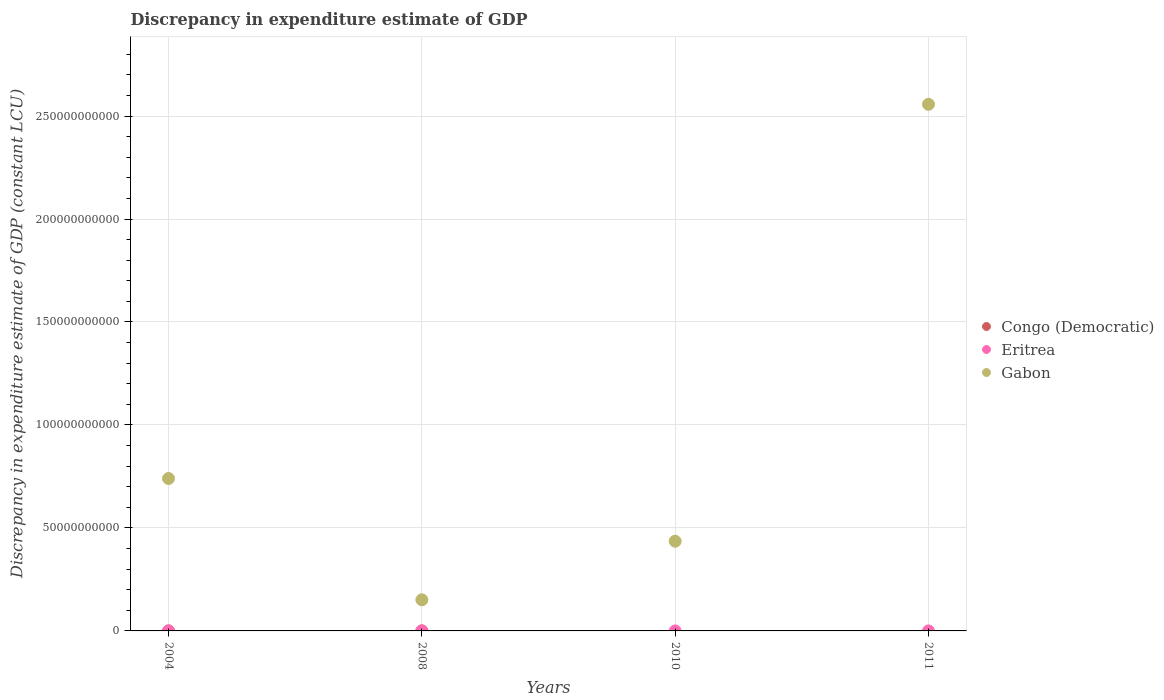What is the discrepancy in expenditure estimate of GDP in Congo (Democratic) in 2004?
Make the answer very short. 0. What is the total discrepancy in expenditure estimate of GDP in Eritrea in the graph?
Keep it short and to the point. 0. What is the difference between the discrepancy in expenditure estimate of GDP in Gabon in 2004 and that in 2008?
Provide a succinct answer. 5.89e+1. What is the difference between the discrepancy in expenditure estimate of GDP in Gabon in 2004 and the discrepancy in expenditure estimate of GDP in Congo (Democratic) in 2008?
Provide a short and direct response. 7.40e+1. In the year 2008, what is the difference between the discrepancy in expenditure estimate of GDP in Gabon and discrepancy in expenditure estimate of GDP in Eritrea?
Your answer should be compact. 1.51e+1. In how many years, is the discrepancy in expenditure estimate of GDP in Eritrea greater than 50000000000 LCU?
Your answer should be very brief. 0. What is the ratio of the discrepancy in expenditure estimate of GDP in Eritrea in 2008 to that in 2010?
Make the answer very short. 0.5. What is the difference between the highest and the second highest discrepancy in expenditure estimate of GDP in Eritrea?
Provide a succinct answer. 0. Is it the case that in every year, the sum of the discrepancy in expenditure estimate of GDP in Congo (Democratic) and discrepancy in expenditure estimate of GDP in Gabon  is greater than the discrepancy in expenditure estimate of GDP in Eritrea?
Make the answer very short. Yes. Is the discrepancy in expenditure estimate of GDP in Gabon strictly less than the discrepancy in expenditure estimate of GDP in Congo (Democratic) over the years?
Provide a short and direct response. No. How many years are there in the graph?
Ensure brevity in your answer.  4. What is the difference between two consecutive major ticks on the Y-axis?
Your response must be concise. 5.00e+1. Does the graph contain grids?
Your response must be concise. Yes. Where does the legend appear in the graph?
Provide a succinct answer. Center right. How many legend labels are there?
Your response must be concise. 3. What is the title of the graph?
Your answer should be very brief. Discrepancy in expenditure estimate of GDP. What is the label or title of the Y-axis?
Your response must be concise. Discrepancy in expenditure estimate of GDP (constant LCU). What is the Discrepancy in expenditure estimate of GDP (constant LCU) of Congo (Democratic) in 2004?
Provide a short and direct response. 0. What is the Discrepancy in expenditure estimate of GDP (constant LCU) in Eritrea in 2004?
Your answer should be very brief. 0. What is the Discrepancy in expenditure estimate of GDP (constant LCU) in Gabon in 2004?
Your answer should be very brief. 7.40e+1. What is the Discrepancy in expenditure estimate of GDP (constant LCU) of Eritrea in 2008?
Make the answer very short. 0. What is the Discrepancy in expenditure estimate of GDP (constant LCU) of Gabon in 2008?
Offer a very short reply. 1.51e+1. What is the Discrepancy in expenditure estimate of GDP (constant LCU) in Gabon in 2010?
Offer a terse response. 4.36e+1. What is the Discrepancy in expenditure estimate of GDP (constant LCU) in Congo (Democratic) in 2011?
Your response must be concise. 0. What is the Discrepancy in expenditure estimate of GDP (constant LCU) of Gabon in 2011?
Your response must be concise. 2.56e+11. Across all years, what is the maximum Discrepancy in expenditure estimate of GDP (constant LCU) in Gabon?
Your answer should be very brief. 2.56e+11. Across all years, what is the minimum Discrepancy in expenditure estimate of GDP (constant LCU) of Gabon?
Make the answer very short. 1.51e+1. What is the total Discrepancy in expenditure estimate of GDP (constant LCU) of Congo (Democratic) in the graph?
Offer a very short reply. 0. What is the total Discrepancy in expenditure estimate of GDP (constant LCU) of Gabon in the graph?
Offer a very short reply. 3.88e+11. What is the difference between the Discrepancy in expenditure estimate of GDP (constant LCU) of Gabon in 2004 and that in 2008?
Keep it short and to the point. 5.89e+1. What is the difference between the Discrepancy in expenditure estimate of GDP (constant LCU) in Eritrea in 2004 and that in 2010?
Keep it short and to the point. -0. What is the difference between the Discrepancy in expenditure estimate of GDP (constant LCU) in Gabon in 2004 and that in 2010?
Make the answer very short. 3.04e+1. What is the difference between the Discrepancy in expenditure estimate of GDP (constant LCU) in Gabon in 2004 and that in 2011?
Your answer should be compact. -1.82e+11. What is the difference between the Discrepancy in expenditure estimate of GDP (constant LCU) in Eritrea in 2008 and that in 2010?
Ensure brevity in your answer.  -0. What is the difference between the Discrepancy in expenditure estimate of GDP (constant LCU) of Gabon in 2008 and that in 2010?
Provide a succinct answer. -2.84e+1. What is the difference between the Discrepancy in expenditure estimate of GDP (constant LCU) of Gabon in 2008 and that in 2011?
Keep it short and to the point. -2.41e+11. What is the difference between the Discrepancy in expenditure estimate of GDP (constant LCU) of Gabon in 2010 and that in 2011?
Offer a terse response. -2.12e+11. What is the difference between the Discrepancy in expenditure estimate of GDP (constant LCU) in Eritrea in 2004 and the Discrepancy in expenditure estimate of GDP (constant LCU) in Gabon in 2008?
Keep it short and to the point. -1.51e+1. What is the difference between the Discrepancy in expenditure estimate of GDP (constant LCU) of Eritrea in 2004 and the Discrepancy in expenditure estimate of GDP (constant LCU) of Gabon in 2010?
Keep it short and to the point. -4.36e+1. What is the difference between the Discrepancy in expenditure estimate of GDP (constant LCU) in Eritrea in 2004 and the Discrepancy in expenditure estimate of GDP (constant LCU) in Gabon in 2011?
Offer a terse response. -2.56e+11. What is the difference between the Discrepancy in expenditure estimate of GDP (constant LCU) in Eritrea in 2008 and the Discrepancy in expenditure estimate of GDP (constant LCU) in Gabon in 2010?
Offer a very short reply. -4.36e+1. What is the difference between the Discrepancy in expenditure estimate of GDP (constant LCU) in Eritrea in 2008 and the Discrepancy in expenditure estimate of GDP (constant LCU) in Gabon in 2011?
Offer a very short reply. -2.56e+11. What is the difference between the Discrepancy in expenditure estimate of GDP (constant LCU) in Eritrea in 2010 and the Discrepancy in expenditure estimate of GDP (constant LCU) in Gabon in 2011?
Offer a very short reply. -2.56e+11. What is the average Discrepancy in expenditure estimate of GDP (constant LCU) in Congo (Democratic) per year?
Make the answer very short. 0. What is the average Discrepancy in expenditure estimate of GDP (constant LCU) in Eritrea per year?
Make the answer very short. 0. What is the average Discrepancy in expenditure estimate of GDP (constant LCU) in Gabon per year?
Provide a succinct answer. 9.71e+1. In the year 2004, what is the difference between the Discrepancy in expenditure estimate of GDP (constant LCU) in Eritrea and Discrepancy in expenditure estimate of GDP (constant LCU) in Gabon?
Offer a very short reply. -7.40e+1. In the year 2008, what is the difference between the Discrepancy in expenditure estimate of GDP (constant LCU) in Eritrea and Discrepancy in expenditure estimate of GDP (constant LCU) in Gabon?
Keep it short and to the point. -1.51e+1. In the year 2010, what is the difference between the Discrepancy in expenditure estimate of GDP (constant LCU) of Eritrea and Discrepancy in expenditure estimate of GDP (constant LCU) of Gabon?
Offer a terse response. -4.36e+1. What is the ratio of the Discrepancy in expenditure estimate of GDP (constant LCU) in Gabon in 2004 to that in 2008?
Provide a succinct answer. 4.9. What is the ratio of the Discrepancy in expenditure estimate of GDP (constant LCU) in Gabon in 2004 to that in 2010?
Make the answer very short. 1.7. What is the ratio of the Discrepancy in expenditure estimate of GDP (constant LCU) of Gabon in 2004 to that in 2011?
Offer a terse response. 0.29. What is the ratio of the Discrepancy in expenditure estimate of GDP (constant LCU) of Eritrea in 2008 to that in 2010?
Make the answer very short. 0.5. What is the ratio of the Discrepancy in expenditure estimate of GDP (constant LCU) in Gabon in 2008 to that in 2010?
Ensure brevity in your answer.  0.35. What is the ratio of the Discrepancy in expenditure estimate of GDP (constant LCU) of Gabon in 2008 to that in 2011?
Provide a short and direct response. 0.06. What is the ratio of the Discrepancy in expenditure estimate of GDP (constant LCU) in Gabon in 2010 to that in 2011?
Offer a terse response. 0.17. What is the difference between the highest and the second highest Discrepancy in expenditure estimate of GDP (constant LCU) in Eritrea?
Provide a succinct answer. 0. What is the difference between the highest and the second highest Discrepancy in expenditure estimate of GDP (constant LCU) of Gabon?
Your answer should be very brief. 1.82e+11. What is the difference between the highest and the lowest Discrepancy in expenditure estimate of GDP (constant LCU) in Eritrea?
Give a very brief answer. 0. What is the difference between the highest and the lowest Discrepancy in expenditure estimate of GDP (constant LCU) of Gabon?
Give a very brief answer. 2.41e+11. 